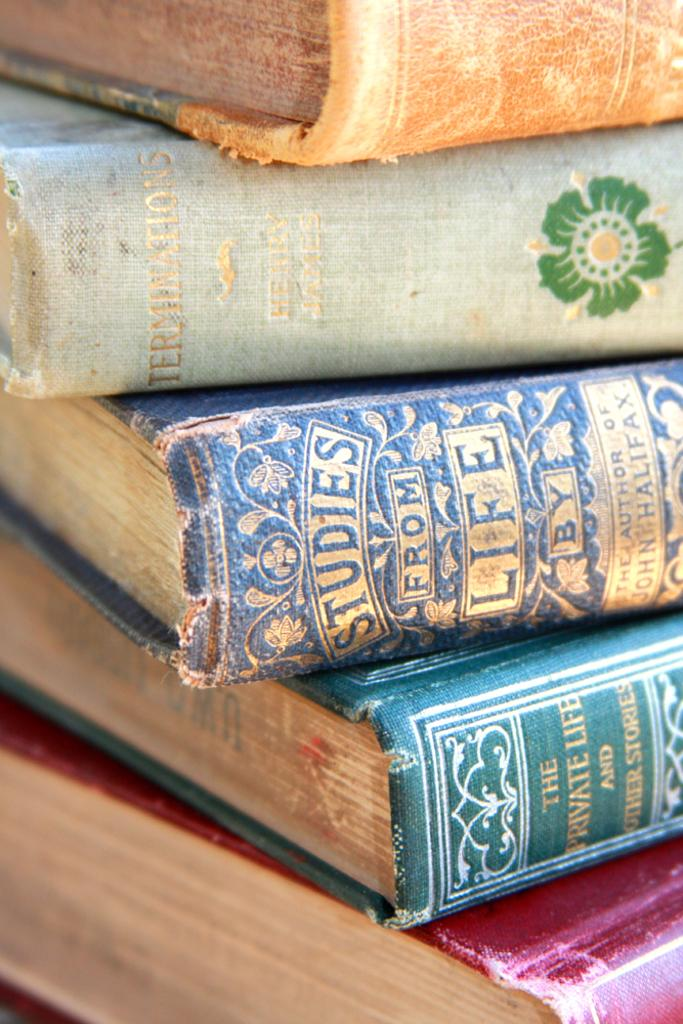<image>
Present a compact description of the photo's key features. Many books stacked on top of one another with one that says STUDIES FROM LIFE. 